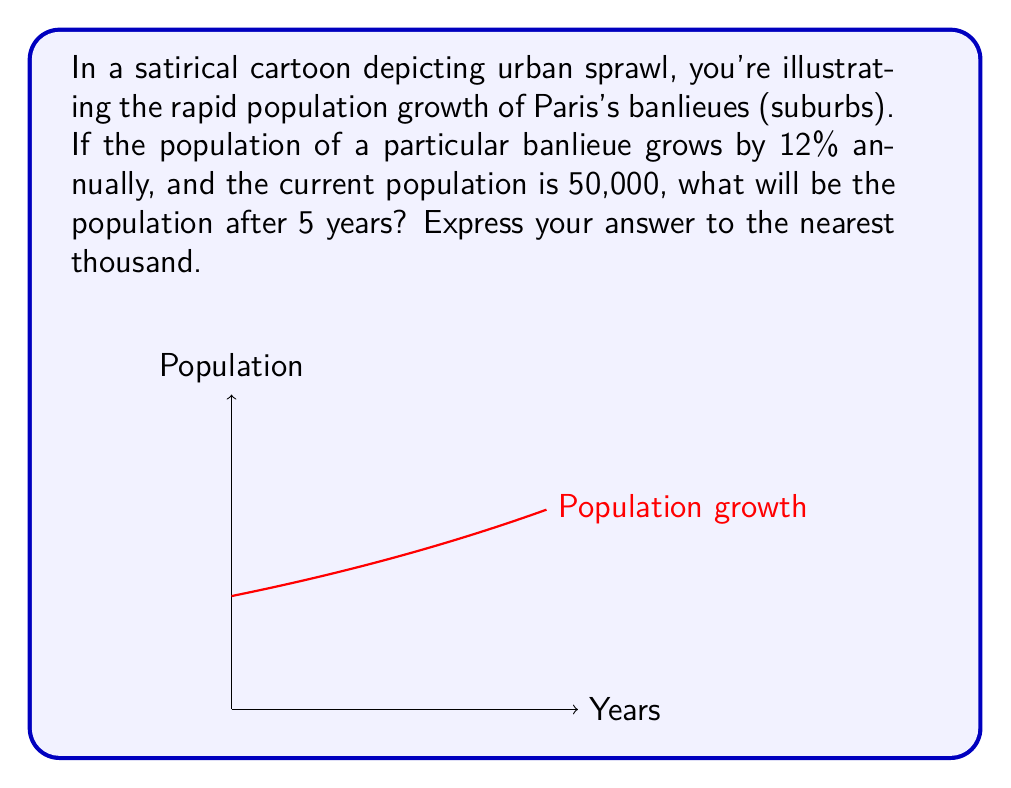Give your solution to this math problem. Let's approach this step-by-step:

1) The initial population is 50,000, and it grows by 12% each year.

2) We can express this as an exponential growth model:
   $P(t) = P_0 \cdot (1 + r)^t$
   Where:
   $P(t)$ is the population after $t$ years
   $P_0$ is the initial population
   $r$ is the growth rate
   $t$ is the number of years

3) In this case:
   $P_0 = 50,000$
   $r = 0.12$ (12% expressed as a decimal)
   $t = 5$ years

4) Let's substitute these values into our equation:
   $P(5) = 50,000 \cdot (1 + 0.12)^5$

5) Simplify:
   $P(5) = 50,000 \cdot (1.12)^5$

6) Calculate:
   $P(5) = 50,000 \cdot 1.7623$ (rounded to 4 decimal places)
   $P(5) = 88,115$ (rounded to the nearest whole number)

7) Rounding to the nearest thousand:
   $P(5) \approx 88,000$
Answer: 88,000 